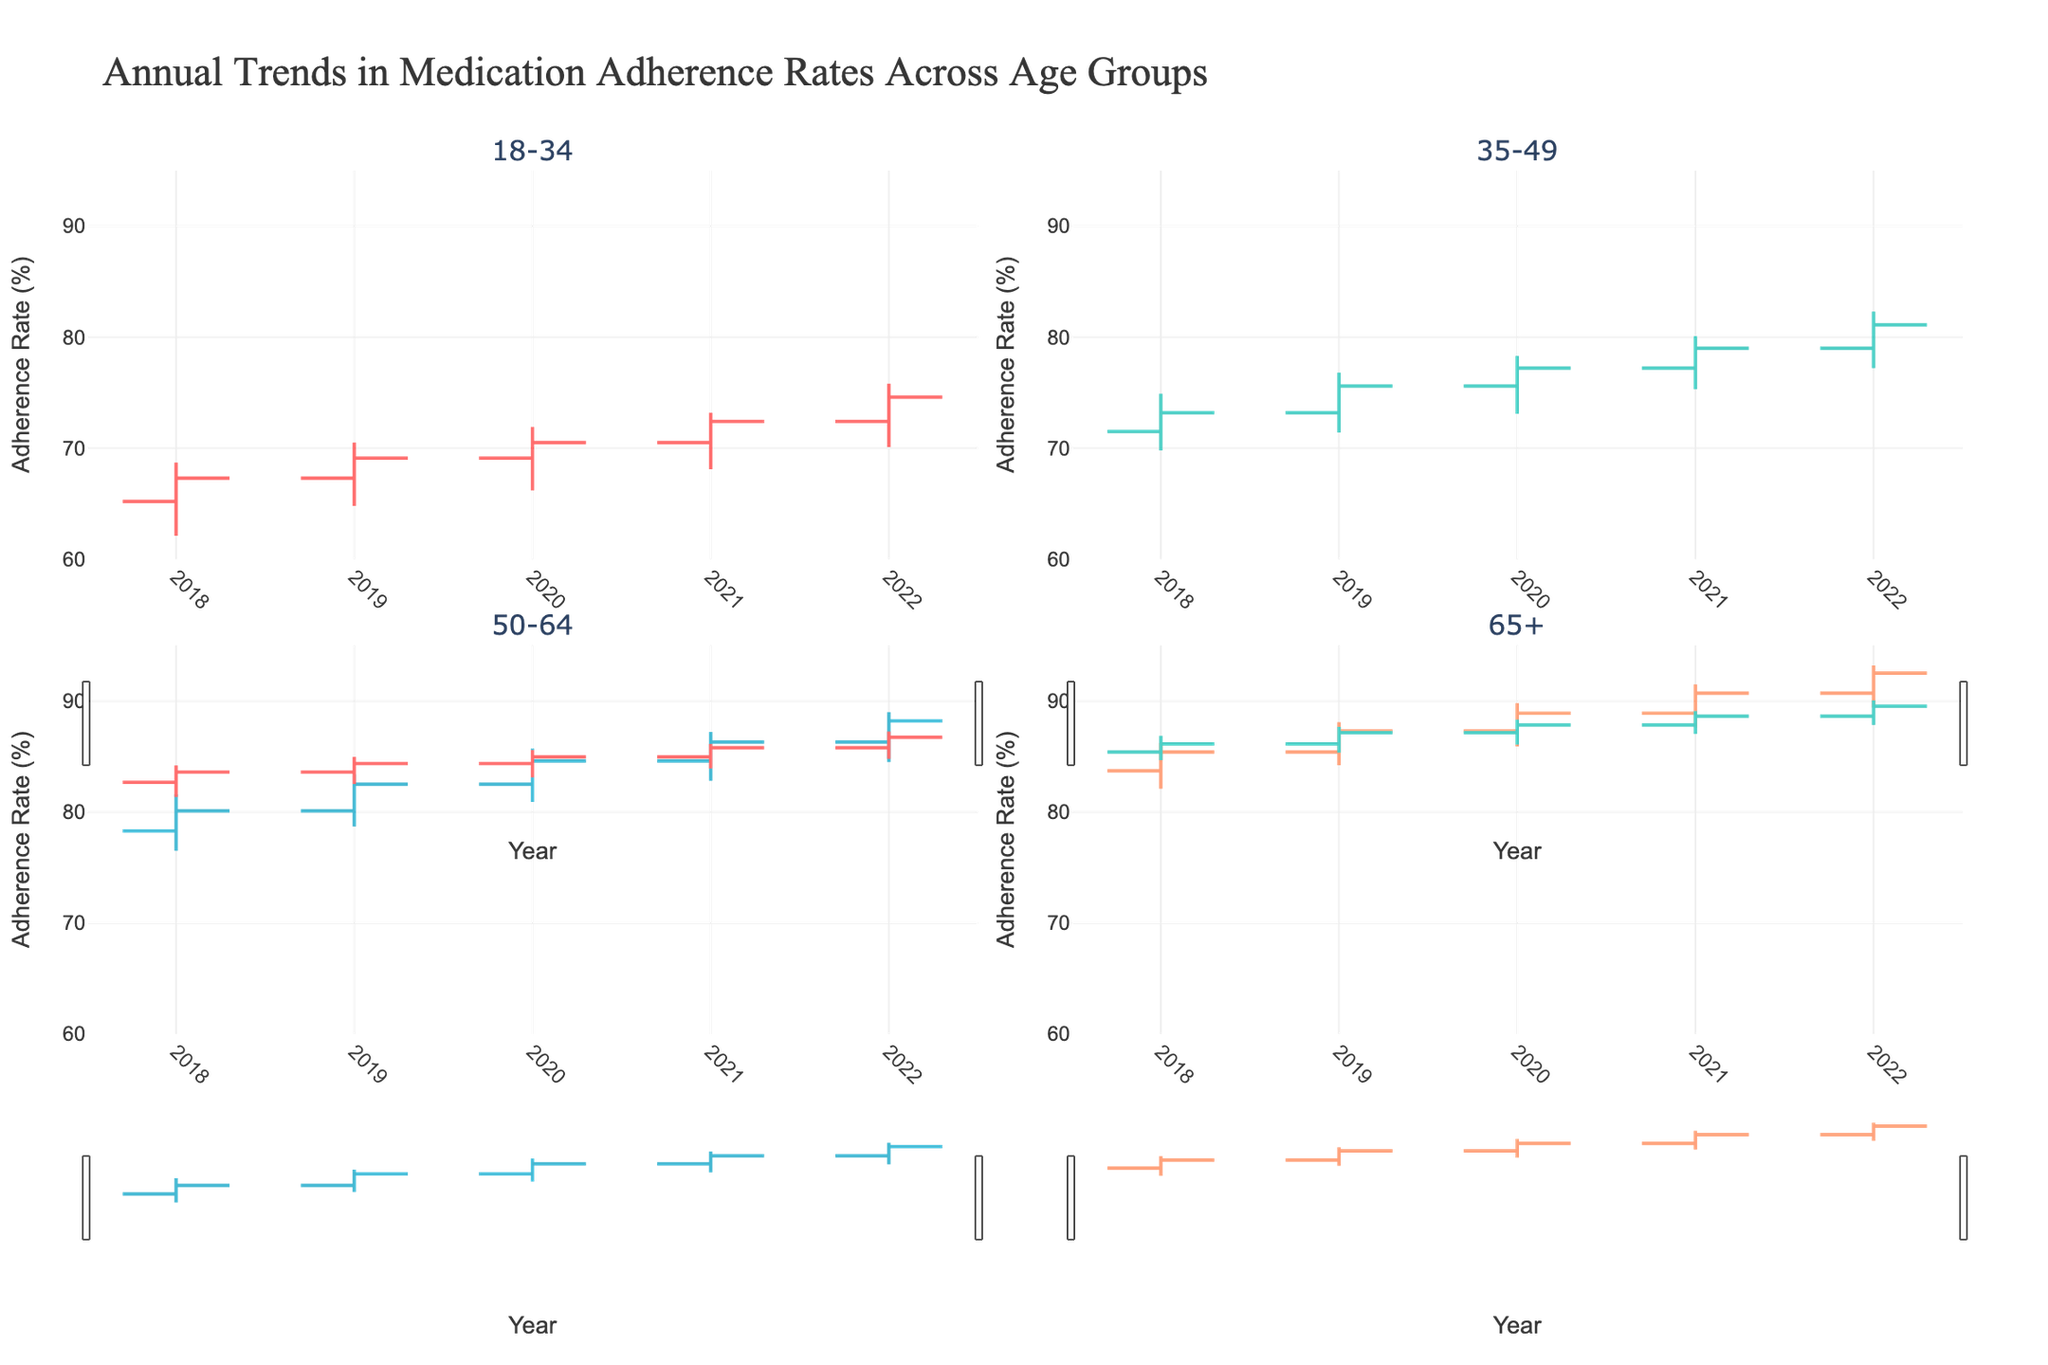What is the title of the figure? The title of the figure is mentioned at the top of the plot and describes what the plot is about.
Answer: Annual Trends in Medication Adherence Rates Across Age Groups What is the adherence rate range for the 65+ age group in 2020? Locate the 65+ subplot for the year 2020, then identify the low and high values. The range is from the lowest to the highest adherence rate.
Answer: 85.9% to 89.8% How did the adherence rate for the 18-34 age group change from 2018 to 2022? Compare the opening adherence rate in 2018 to the closing adherence rate in 2022 for the 18-34 age group in their respective subplots.
Answer: Increased from 65.2% to 74.6% Which age group had the highest adherence rate in 2021? Identify the highest close value across all age groups for the year 2021.
Answer: 65+ age group Which age group showed the most improvement in adherence rate from the beginning to the end of 2019? Calculate the difference between the open and close values for 2019 for each age group and identify the group with the largest positive difference.
Answer: 35-49 What is the average high adherence rate for the 50-64 age group between 2018 and 2022? Sum the high values for each year (81.6, 83.4, 85.7, 87.2, 89.0) and divide by the number of years. Detailed steps: (81.6 + 83.4 + 85.7 + 87.2 + 89.0) / 5 = 85.38
Answer: 85.38% Did any age group experience a decrease in their adherence rate from 2021 to 2022? Compare the close values for each age group between 2021 and 2022 and note if any of them show a decrease.
Answer: No What was the closing adherence rate for the 18-34 age group in 2020? Locate the 18-34 subplot for 2020 and identify the closing adherence rate.
Answer: 70.5% In 2019, which age group had the smallest difference between the high and low adherence rates? Calculate the difference between the high and low values for each age group in 2019 and identify the smallest difference.
Answer: 18-34 Which age group consistently had the highest adherence rates every year from 2018 to 2022? Compare the adherence rates for each age group across all years and identify the group with the highest rates annually.
Answer: 65+ age group 